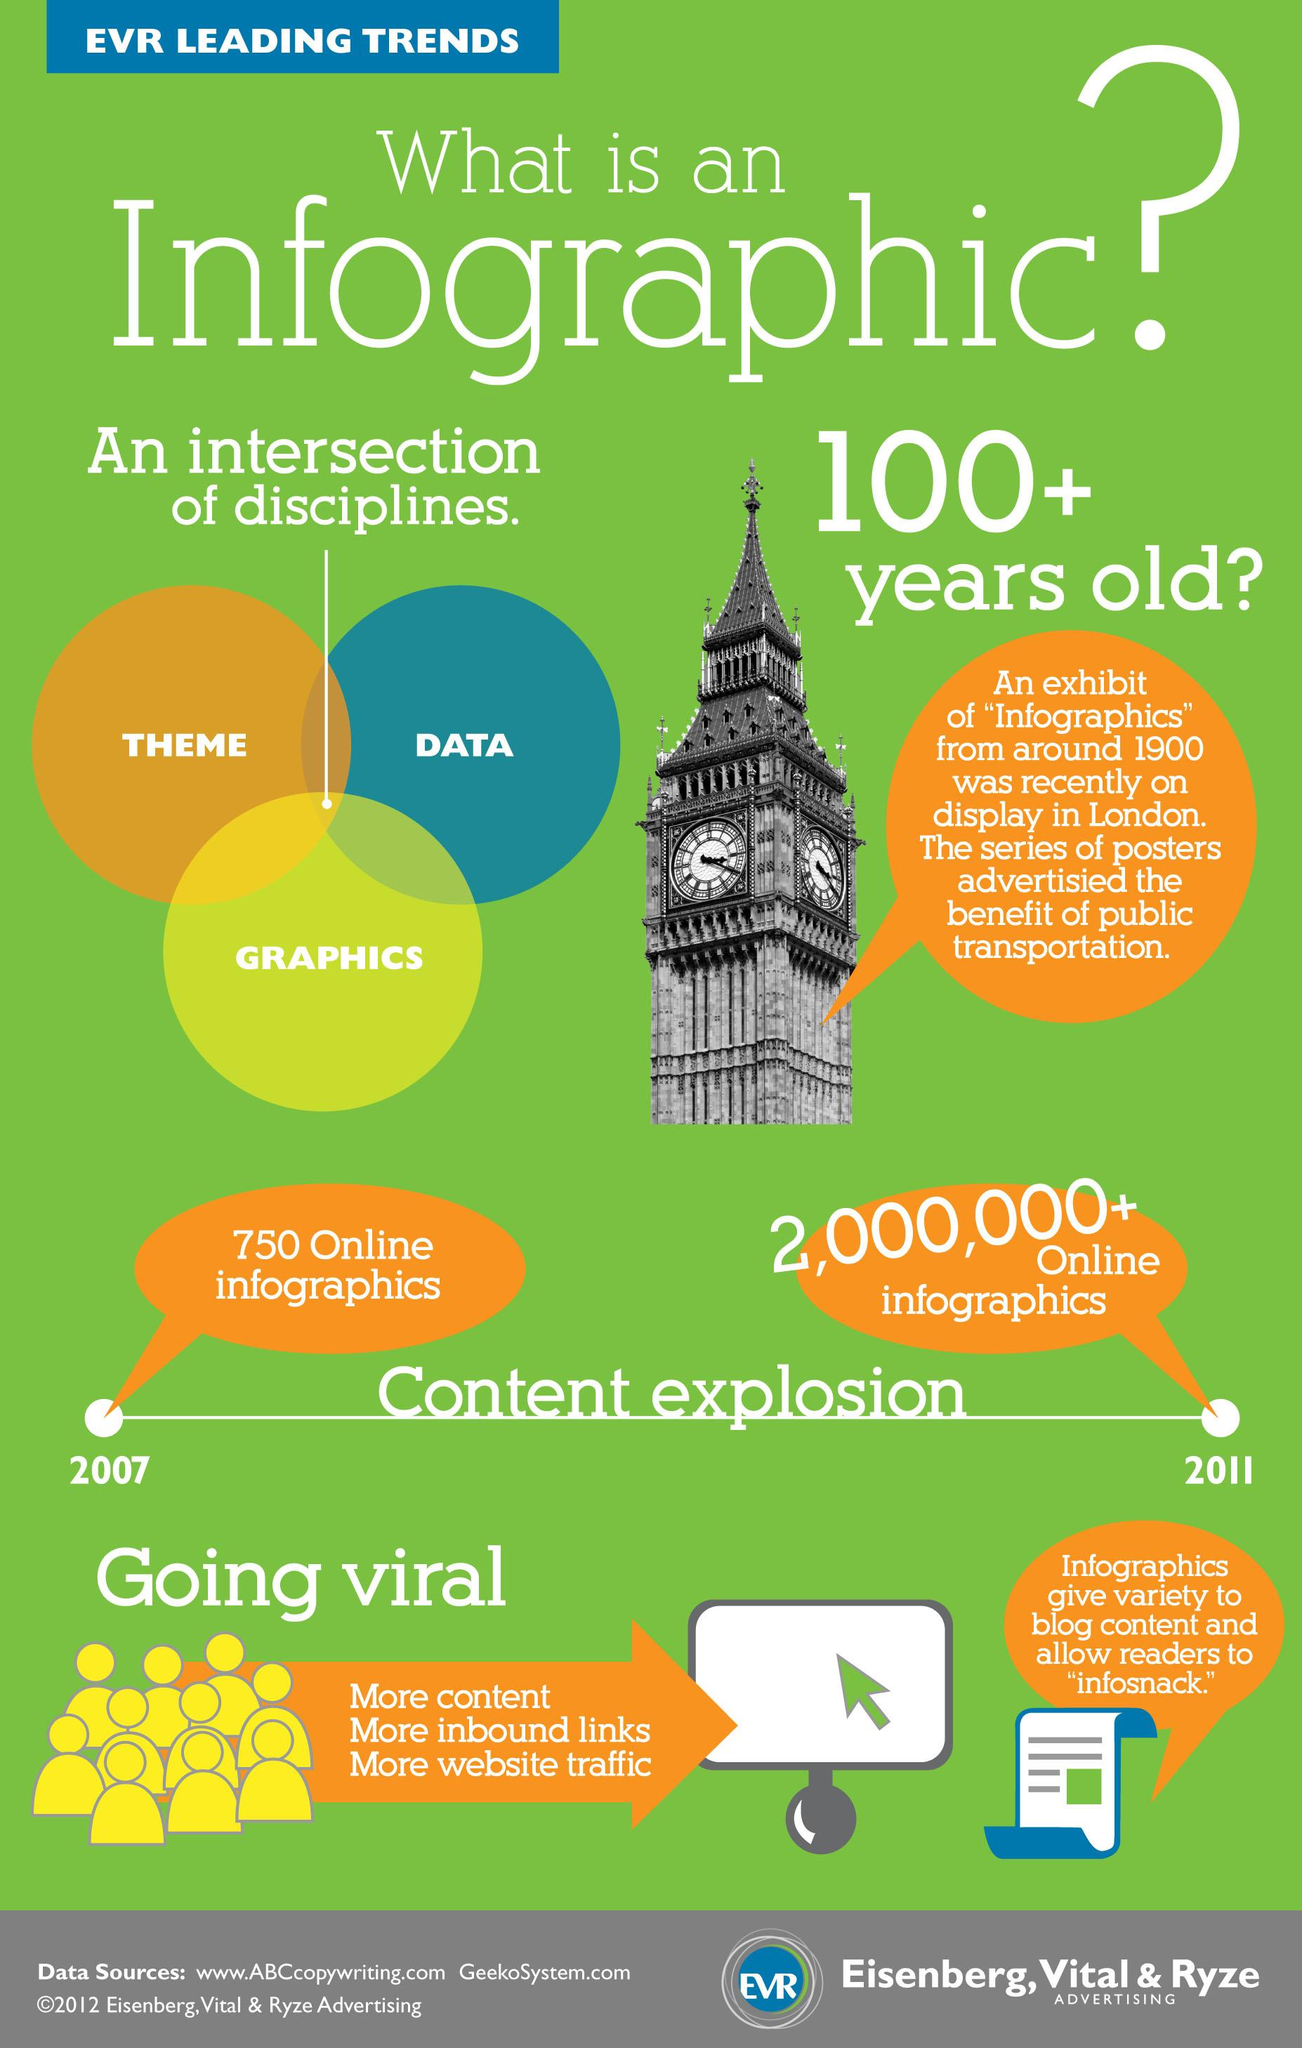Indicate a few pertinent items in this graphic. The color that represents discipline in graphics is yellow. 